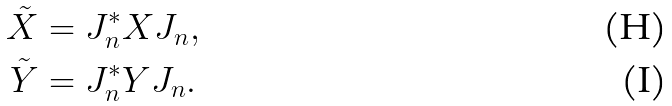Convert formula to latex. <formula><loc_0><loc_0><loc_500><loc_500>\tilde { X } & = J _ { n } ^ { * } X J _ { n } , \\ \tilde { Y } & = J _ { n } ^ { * } Y J _ { n } .</formula> 